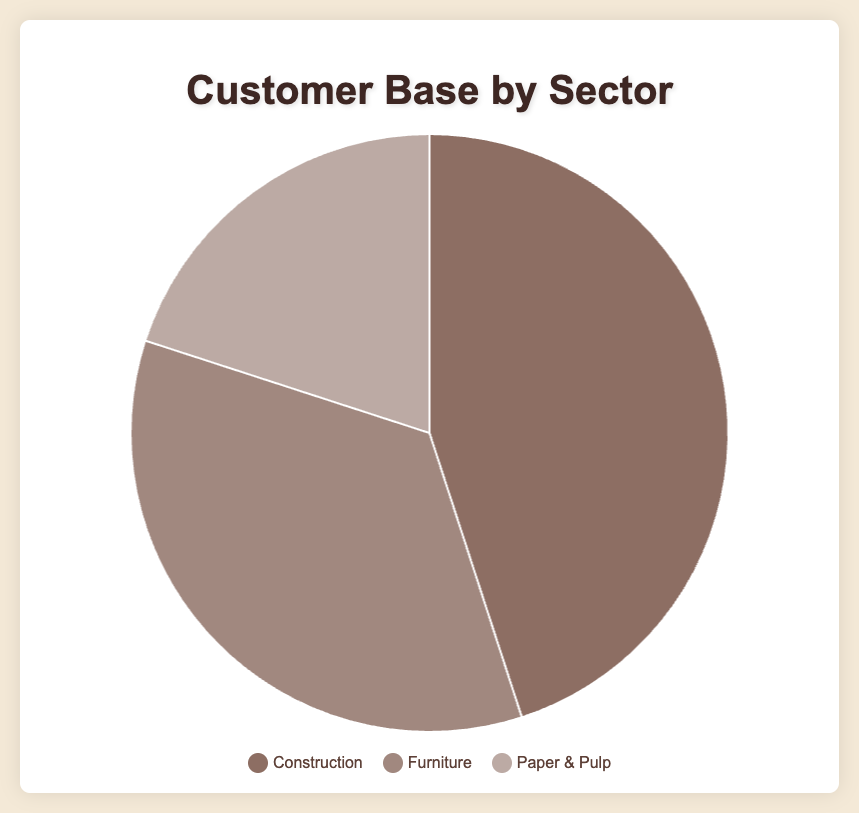How many sectors are represented in the pie chart? The pie chart displays data from three different sectors, each represented by a different segment of the chart.
Answer: 3 Which sector has the largest customer base percentage? By observing the size of the segments, it's clear that the "Construction" segment is the largest, representing 45% of the customer base.
Answer: Construction What is the combined percentage of Furniture and Paper & Pulp sectors? The Furniture sector represents 35% and the Paper & Pulp sector represents 20%. Adding these together gives 35% + 20% = 55%.
Answer: 55% How does the Furniture customer base percentage compare to the Paper & Pulp customer base percentage? The Furniture sector makes up 35% of the customer base, while the Paper & Pulp sector makes up 20%. Thus, the Furniture customer base is larger.
Answer: Furniture is larger What color represents the Construction sector in the pie chart? The legend shows that the Construction sector is represented by the color brown.
Answer: Brown Which sector has the smallest percentage, and what is that percentage? By identifying the smallest segment in the pie chart, the Paper & Pulp sector is the smallest with 20%.
Answer: Paper & Pulp, 20% What is the percentage difference between the Construction sector and the Furniture sector? The Construction sector constitutes 45% while the Furniture sector constitutes 35%. Subtracting these values gives 45% - 35% = 10%.
Answer: 10% If the Furniture and Paper & Pulp sectors percentages were combined, would they exceed the Construction sector percentage? Furniture (35%) + Paper & Pulp (20%) = 55%. Since 55% is greater than 45%, the combined percentage exceeds that of Construction.
Answer: Yes What color is used to represent the Furniture sector? The legend indicates that the Furniture sector is represented by the color light brown.
Answer: Light brown How much greater is the combined Furniture and Paper & Pulp percentage compared to the Construction sector percentage? The combined Furniture and Paper & Pulp sectors represent 55%. The Construction sector represents 45%. The difference is 55% - 45% = 10%.
Answer: 10% 